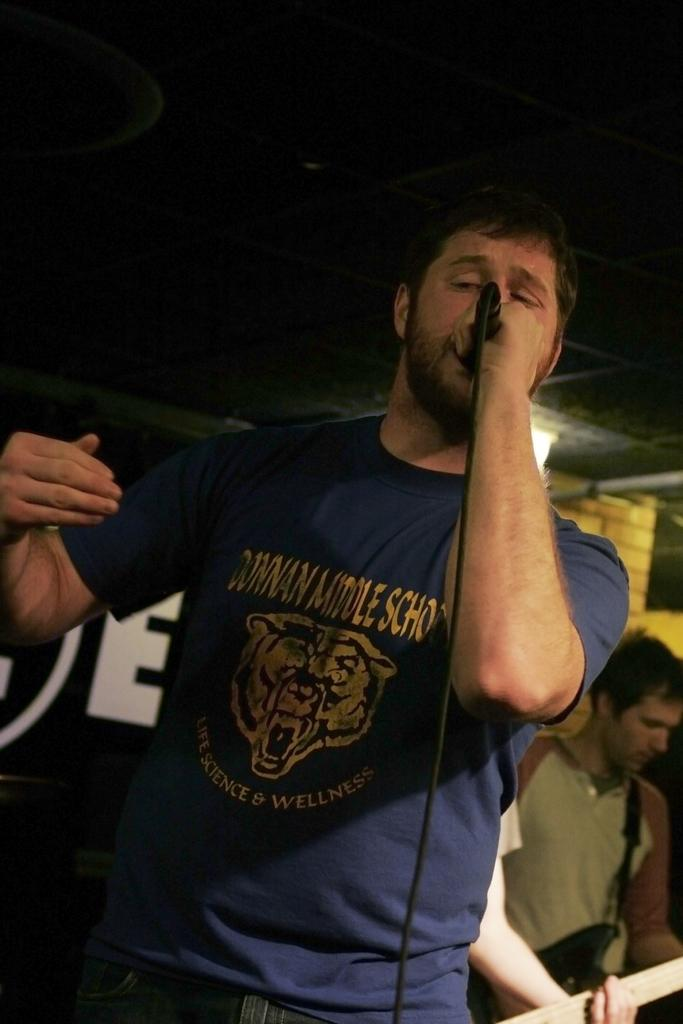What is the man in the image holding in his hand? The man is holding a mic in his hand. Can you describe the other man in the image? The second man is holding a guitar in his hand. What might the two men be doing together in the image? They might be performing or rehearsing a musical act, given that one is holding a mic and the other a guitar. What type of tent can be seen in the background of the image? There is no tent present in the image. What kind of feast is being prepared by the men in the image? There is no feast being prepared in the image; the men are holding a mic and a guitar, suggesting a musical context. 